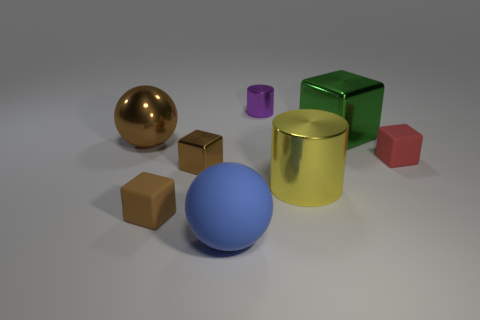What shape is the small metal object that is the same color as the big shiny sphere?
Keep it short and to the point. Cube. Is the number of big green objects to the left of the big blue rubber ball the same as the number of large green cubes?
Offer a very short reply. No. There is a big ball left of the blue sphere; does it have the same color as the rubber block that is on the left side of the purple metallic cylinder?
Provide a succinct answer. Yes. What number of spheres are left of the blue matte object and in front of the large metallic cylinder?
Offer a terse response. 0. What number of other objects are the same shape as the big blue matte thing?
Make the answer very short. 1. Is the number of metallic cubes behind the large brown object greater than the number of green balls?
Your answer should be very brief. Yes. What color is the tiny shiny thing in front of the large green cube?
Your response must be concise. Brown. There is a metallic ball that is the same color as the tiny metallic block; what size is it?
Provide a succinct answer. Large. How many rubber things are either blocks or big blue spheres?
Keep it short and to the point. 3. Are there any small shiny things on the right side of the sphere on the right side of the shiny block that is in front of the red cube?
Provide a short and direct response. Yes. 